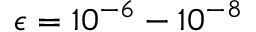<formula> <loc_0><loc_0><loc_500><loc_500>\epsilon = 1 0 ^ { - 6 } - 1 0 ^ { - 8 }</formula> 